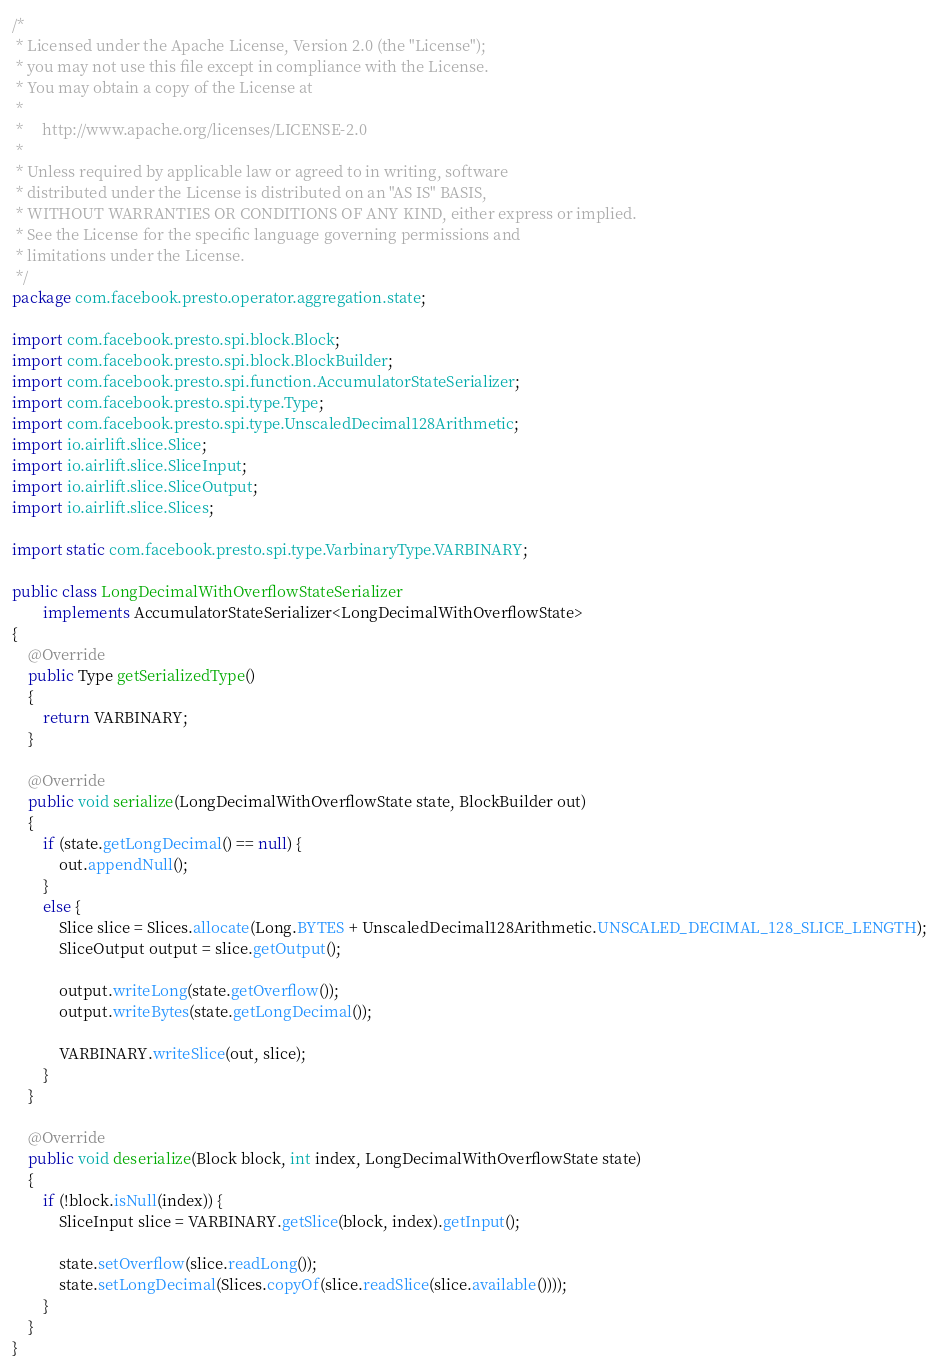Convert code to text. <code><loc_0><loc_0><loc_500><loc_500><_Java_>/*
 * Licensed under the Apache License, Version 2.0 (the "License");
 * you may not use this file except in compliance with the License.
 * You may obtain a copy of the License at
 *
 *     http://www.apache.org/licenses/LICENSE-2.0
 *
 * Unless required by applicable law or agreed to in writing, software
 * distributed under the License is distributed on an "AS IS" BASIS,
 * WITHOUT WARRANTIES OR CONDITIONS OF ANY KIND, either express or implied.
 * See the License for the specific language governing permissions and
 * limitations under the License.
 */
package com.facebook.presto.operator.aggregation.state;

import com.facebook.presto.spi.block.Block;
import com.facebook.presto.spi.block.BlockBuilder;
import com.facebook.presto.spi.function.AccumulatorStateSerializer;
import com.facebook.presto.spi.type.Type;
import com.facebook.presto.spi.type.UnscaledDecimal128Arithmetic;
import io.airlift.slice.Slice;
import io.airlift.slice.SliceInput;
import io.airlift.slice.SliceOutput;
import io.airlift.slice.Slices;

import static com.facebook.presto.spi.type.VarbinaryType.VARBINARY;

public class LongDecimalWithOverflowStateSerializer
        implements AccumulatorStateSerializer<LongDecimalWithOverflowState>
{
    @Override
    public Type getSerializedType()
    {
        return VARBINARY;
    }

    @Override
    public void serialize(LongDecimalWithOverflowState state, BlockBuilder out)
    {
        if (state.getLongDecimal() == null) {
            out.appendNull();
        }
        else {
            Slice slice = Slices.allocate(Long.BYTES + UnscaledDecimal128Arithmetic.UNSCALED_DECIMAL_128_SLICE_LENGTH);
            SliceOutput output = slice.getOutput();

            output.writeLong(state.getOverflow());
            output.writeBytes(state.getLongDecimal());

            VARBINARY.writeSlice(out, slice);
        }
    }

    @Override
    public void deserialize(Block block, int index, LongDecimalWithOverflowState state)
    {
        if (!block.isNull(index)) {
            SliceInput slice = VARBINARY.getSlice(block, index).getInput();

            state.setOverflow(slice.readLong());
            state.setLongDecimal(Slices.copyOf(slice.readSlice(slice.available())));
        }
    }
}
</code> 